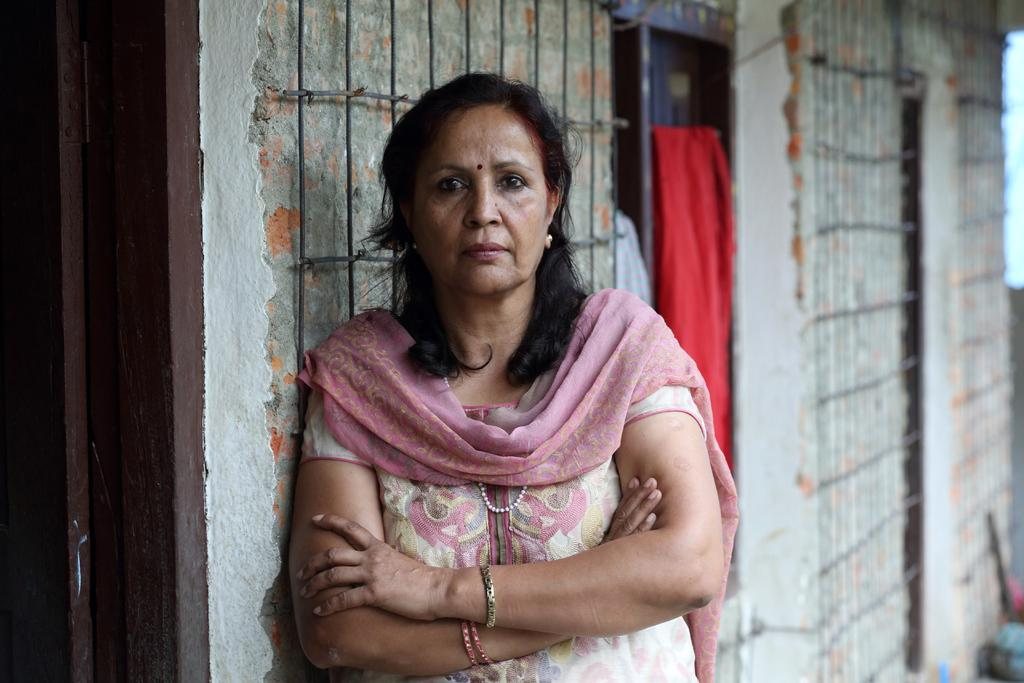Who is present in the image? There is a lady in the image. What is the lady doing in the image? The lady is standing beside a wall. What color is the cloth visible in the image? There is a red cloth visible in the image. What architectural feature can be seen in the image? There is a door in the image. Are there any ants crawling on the lady in the image? There is no indication of ants in the image; the focus is on the lady, the wall, the red cloth, and the door. 